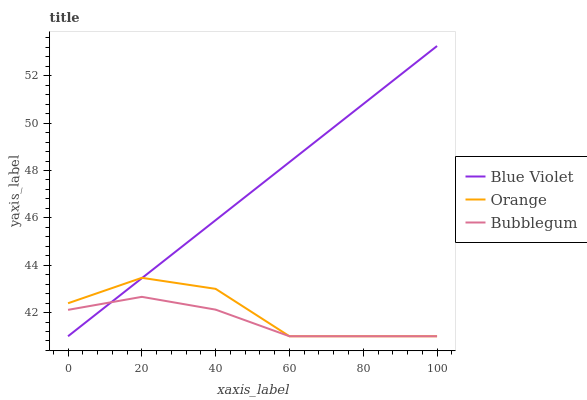Does Bubblegum have the minimum area under the curve?
Answer yes or no. Yes. Does Blue Violet have the maximum area under the curve?
Answer yes or no. Yes. Does Blue Violet have the minimum area under the curve?
Answer yes or no. No. Does Bubblegum have the maximum area under the curve?
Answer yes or no. No. Is Blue Violet the smoothest?
Answer yes or no. Yes. Is Orange the roughest?
Answer yes or no. Yes. Is Bubblegum the smoothest?
Answer yes or no. No. Is Bubblegum the roughest?
Answer yes or no. No. Does Blue Violet have the highest value?
Answer yes or no. Yes. Does Bubblegum have the highest value?
Answer yes or no. No. Does Bubblegum intersect Orange?
Answer yes or no. Yes. Is Bubblegum less than Orange?
Answer yes or no. No. Is Bubblegum greater than Orange?
Answer yes or no. No. 